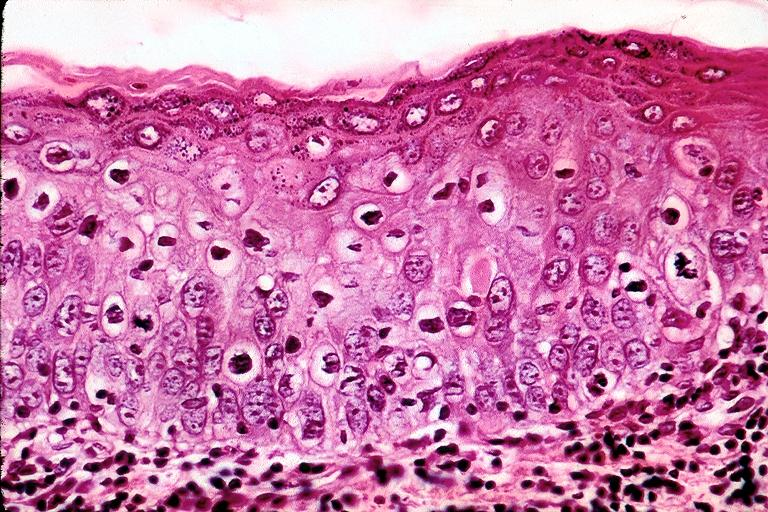does this image show mild-moderate epithelial dysplasia?
Answer the question using a single word or phrase. Yes 